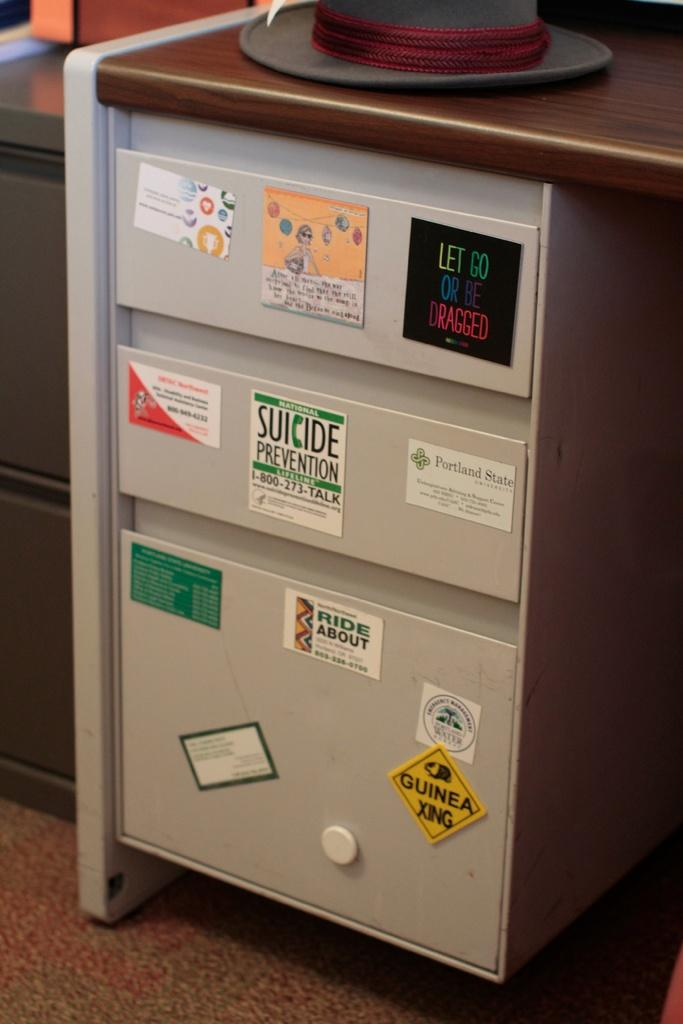What is the main object in the image? There is a rack in the image. What color is the rack? The rack is white in color. Are there any decorations or additions on the rack? Yes, there are stickers attached to the rack. What else can be seen in the image besides the rack? There is a table visible in the image. How many legs does the week have in the image? There is no week present in the image, and therefore no legs can be counted. 